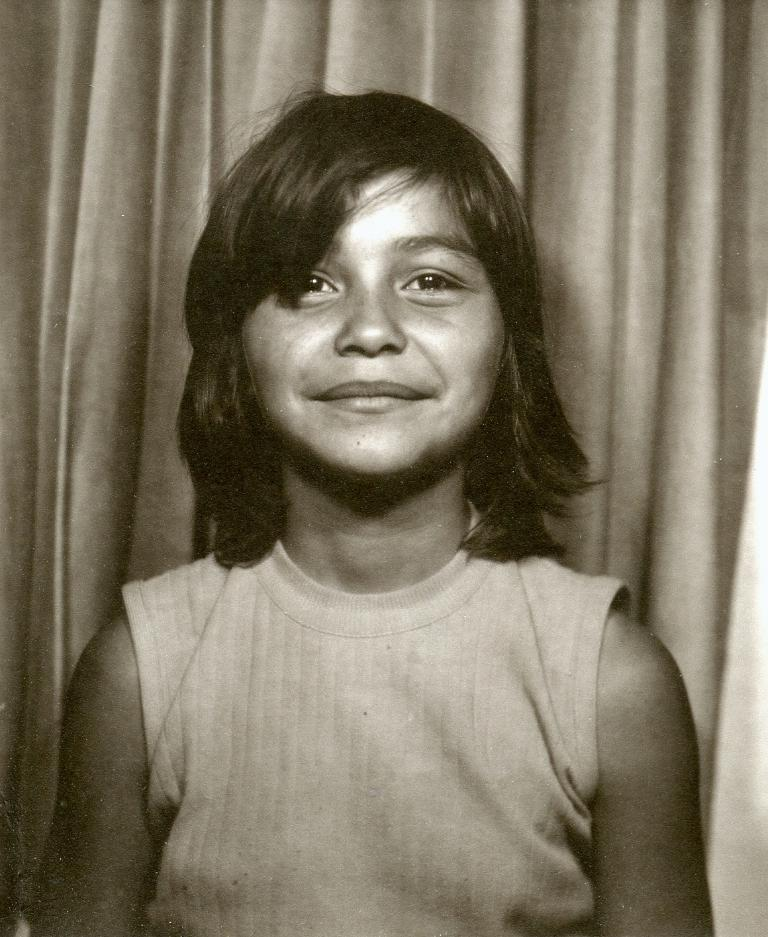Who is the main subject in the image? There is a girl in the image. What is the girl wearing? The girl is wearing a t-shirt. What else can be seen in the background of the image? There is a curtain visible in the image. What type of canvas is the girl painting on in the image? There is no canvas or painting activity present in the image. What kind of flower is the girl holding in the image? There is no flower present in the image. 